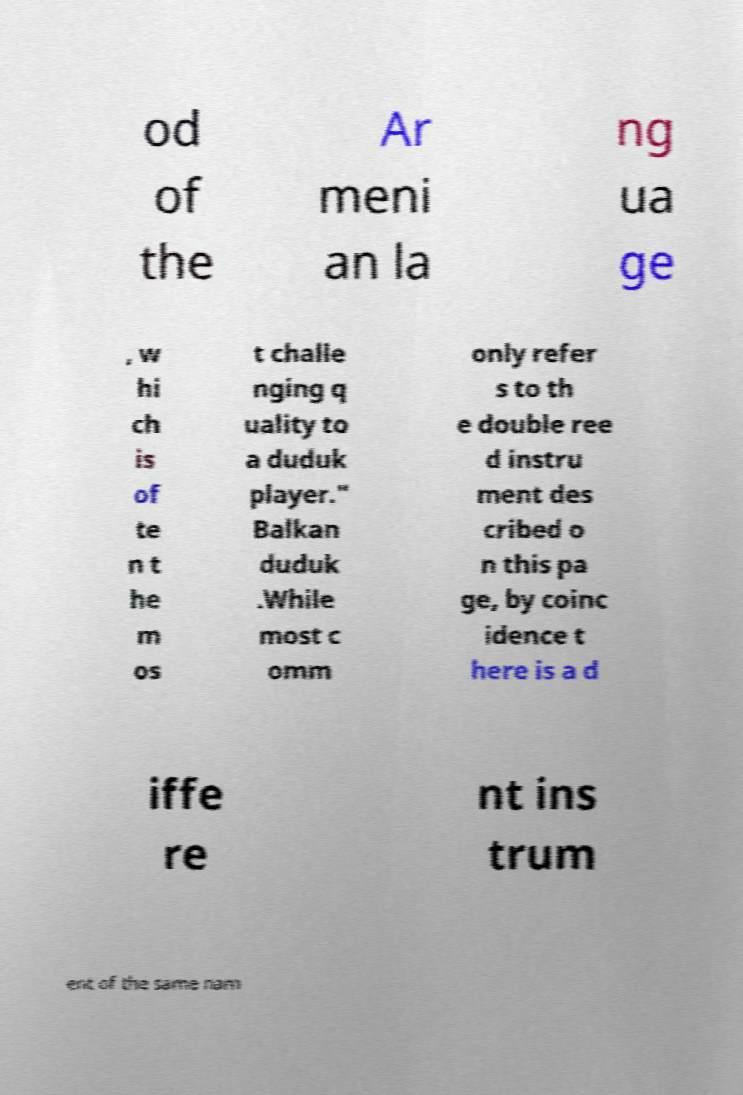I need the written content from this picture converted into text. Can you do that? od of the Ar meni an la ng ua ge , w hi ch is of te n t he m os t challe nging q uality to a duduk player." Balkan duduk .While most c omm only refer s to th e double ree d instru ment des cribed o n this pa ge, by coinc idence t here is a d iffe re nt ins trum ent of the same nam 